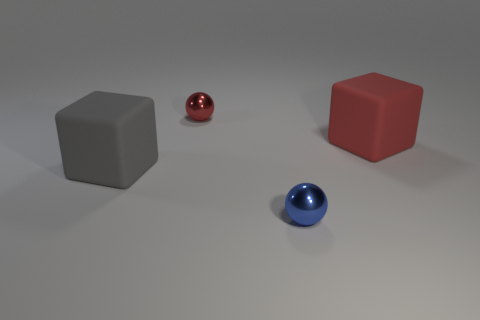What shape is the metal object behind the big thing that is left of the tiny red metallic ball?
Your answer should be very brief. Sphere. How many cylinders are big red matte things or large gray rubber objects?
Provide a short and direct response. 0. Does the red thing that is behind the red block have the same shape as the large red object behind the small blue thing?
Your answer should be compact. No. What is the color of the object that is both on the left side of the blue metal object and behind the gray matte object?
Ensure brevity in your answer.  Red. How big is the object that is right of the gray rubber thing and on the left side of the blue shiny object?
Provide a short and direct response. Small. There is a rubber cube left of the matte cube that is on the right side of the red metallic object that is on the left side of the blue object; what size is it?
Offer a terse response. Large. There is a blue metal ball; are there any tiny blue objects on the left side of it?
Your answer should be very brief. No. Do the red cube and the rubber object to the left of the red matte cube have the same size?
Provide a short and direct response. Yes. There is a thing that is right of the gray rubber object and to the left of the blue metal ball; what shape is it?
Offer a very short reply. Sphere. Do the cube that is to the right of the big gray cube and the ball that is behind the gray matte object have the same size?
Provide a succinct answer. No. 